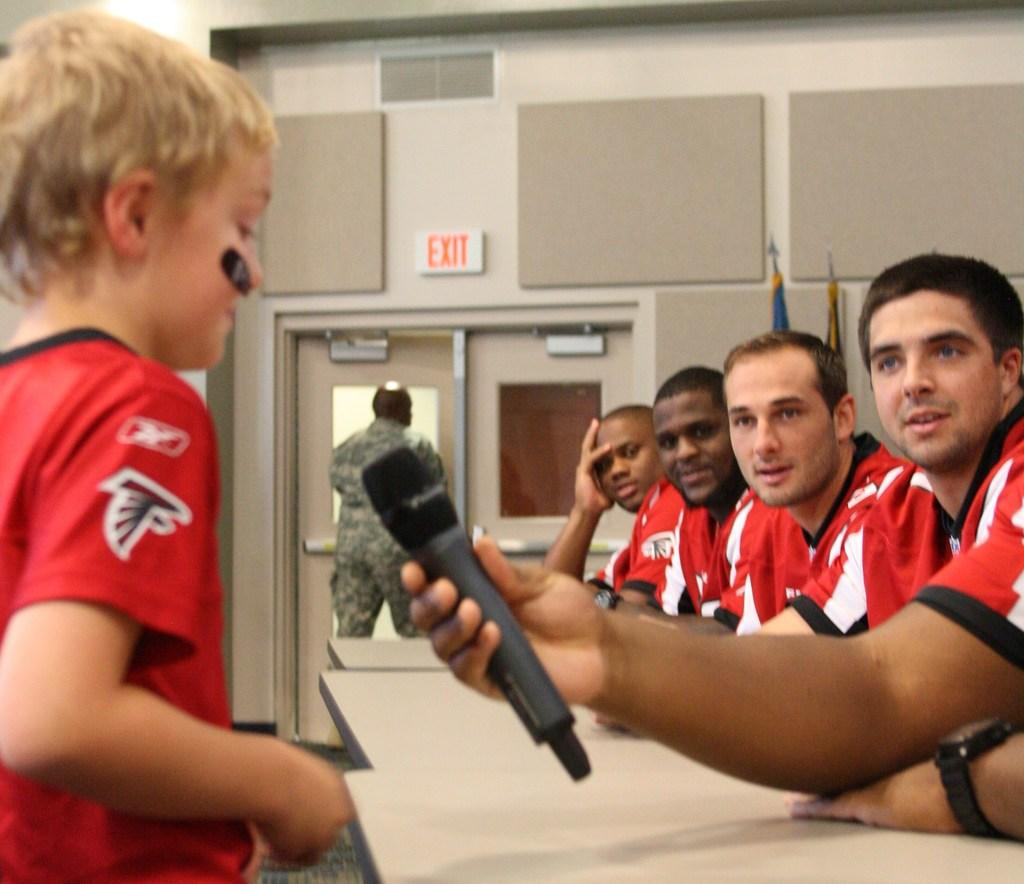Provide a one-sentence caption for the provided image. Several men in red jerseys speak to a child, while there is an EXIT sign in the background. 